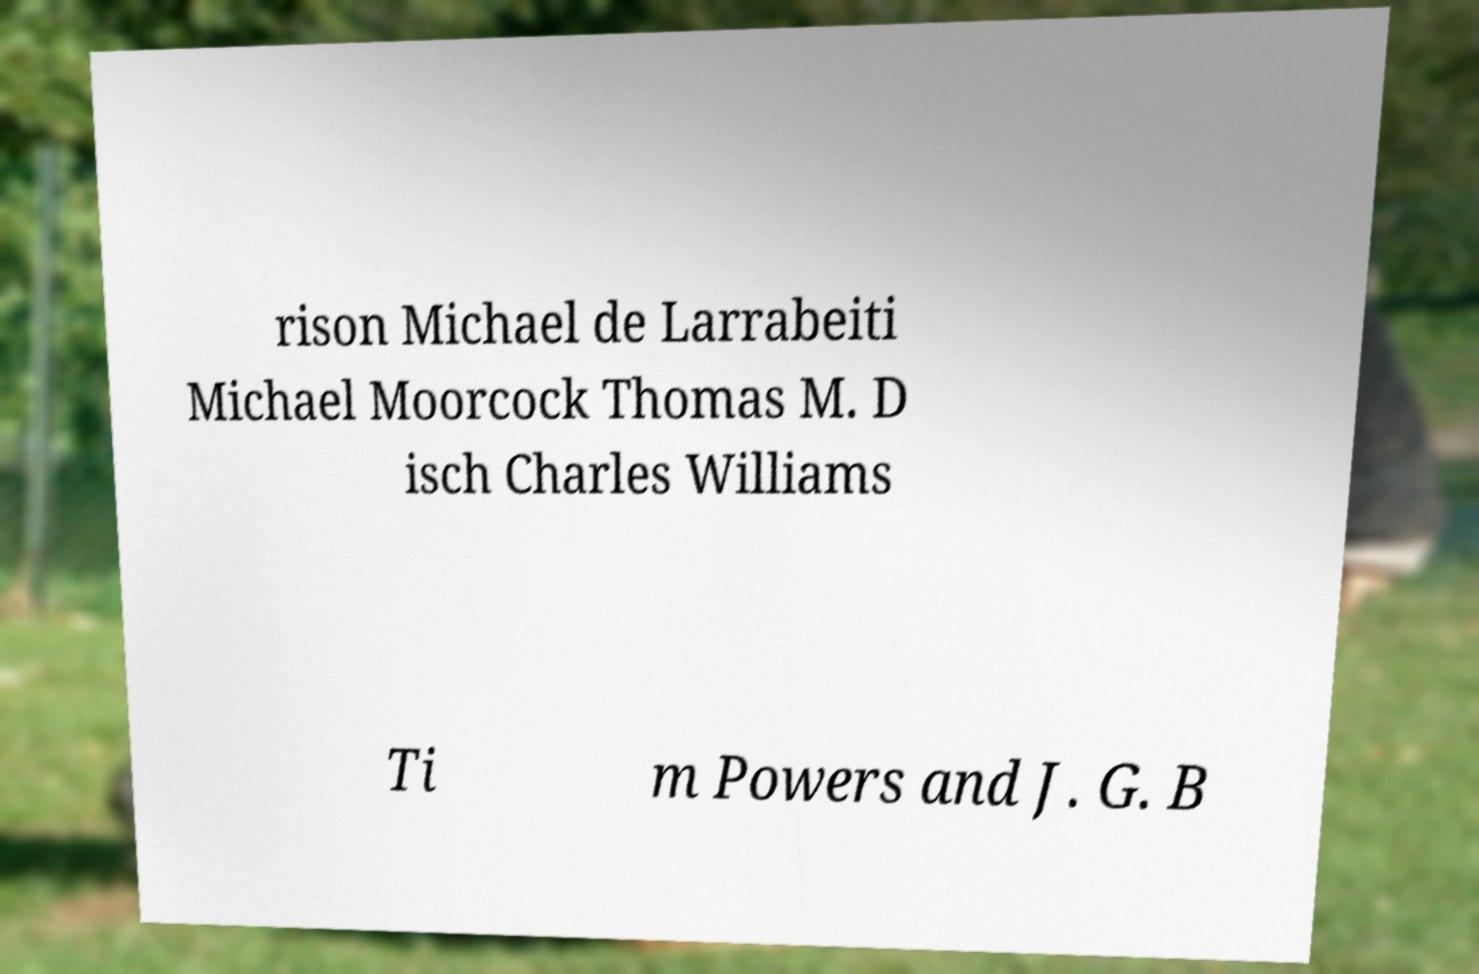There's text embedded in this image that I need extracted. Can you transcribe it verbatim? rison Michael de Larrabeiti Michael Moorcock Thomas M. D isch Charles Williams Ti m Powers and J. G. B 